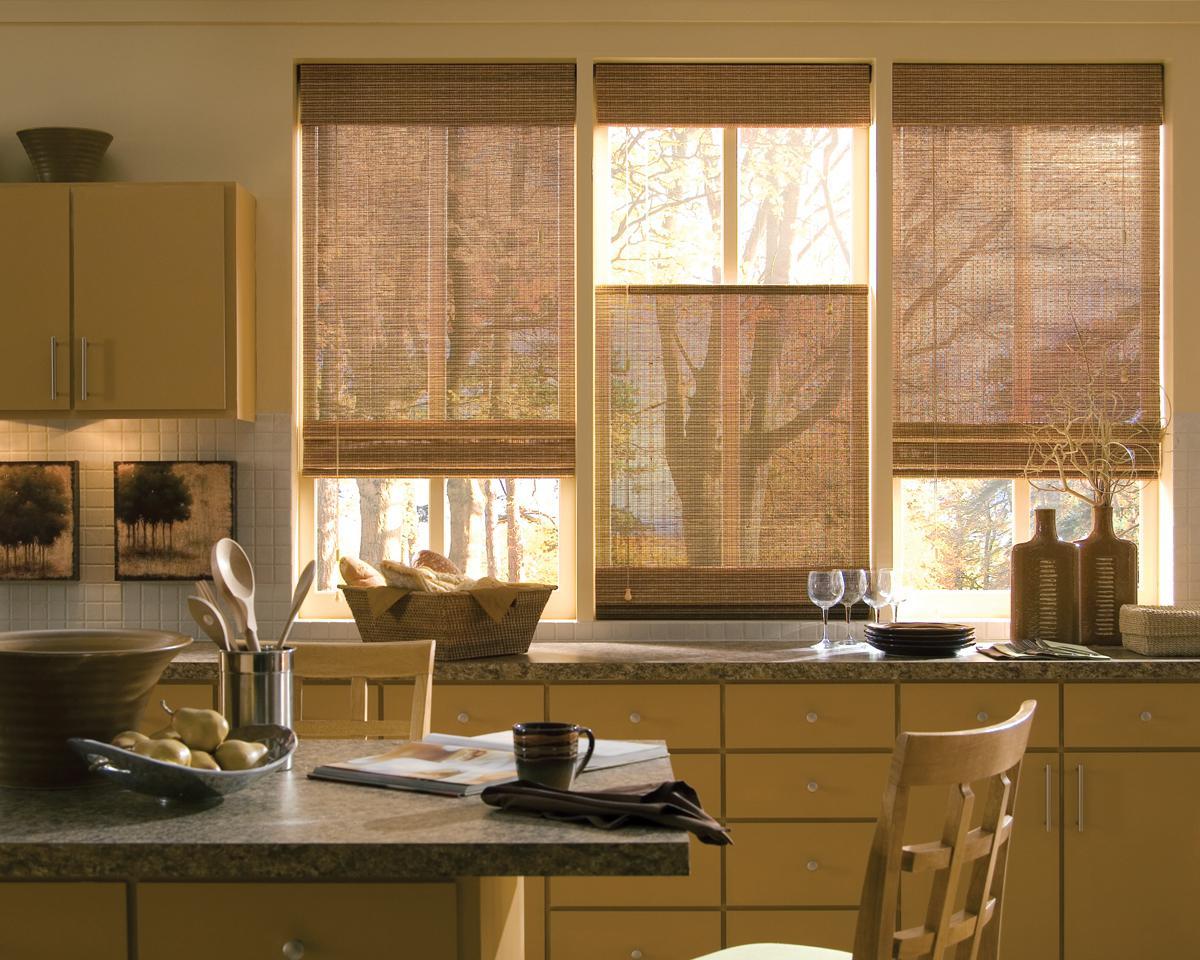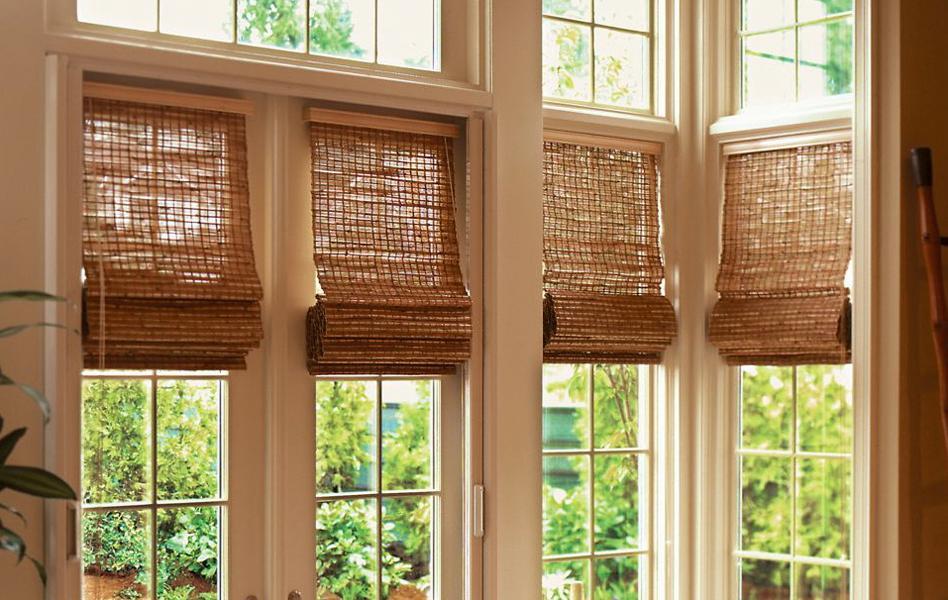The first image is the image on the left, the second image is the image on the right. Examine the images to the left and right. Is the description "A couch is backed up against a row of windows in one of the images." accurate? Answer yes or no. No. The first image is the image on the left, the second image is the image on the right. Assess this claim about the two images: "There are five shades.". Correct or not? Answer yes or no. No. 